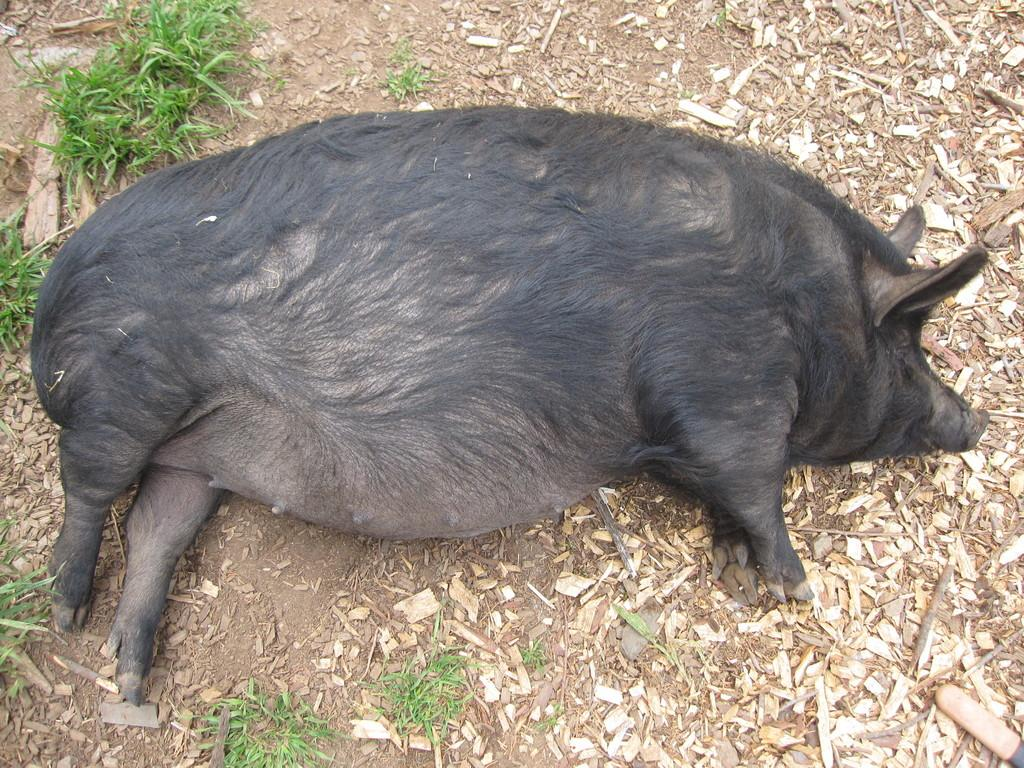What animal can be seen in the image? There is a pig in the image. What is the pig's position in the image? The pig is lying on the land. What type of waste is present in the image? There is some trash in the image. What type of vegetation is present in the image? There is grass in the image. What color is the ink used to write on the pig in the image? There is no ink or writing present on the pig in the image. 